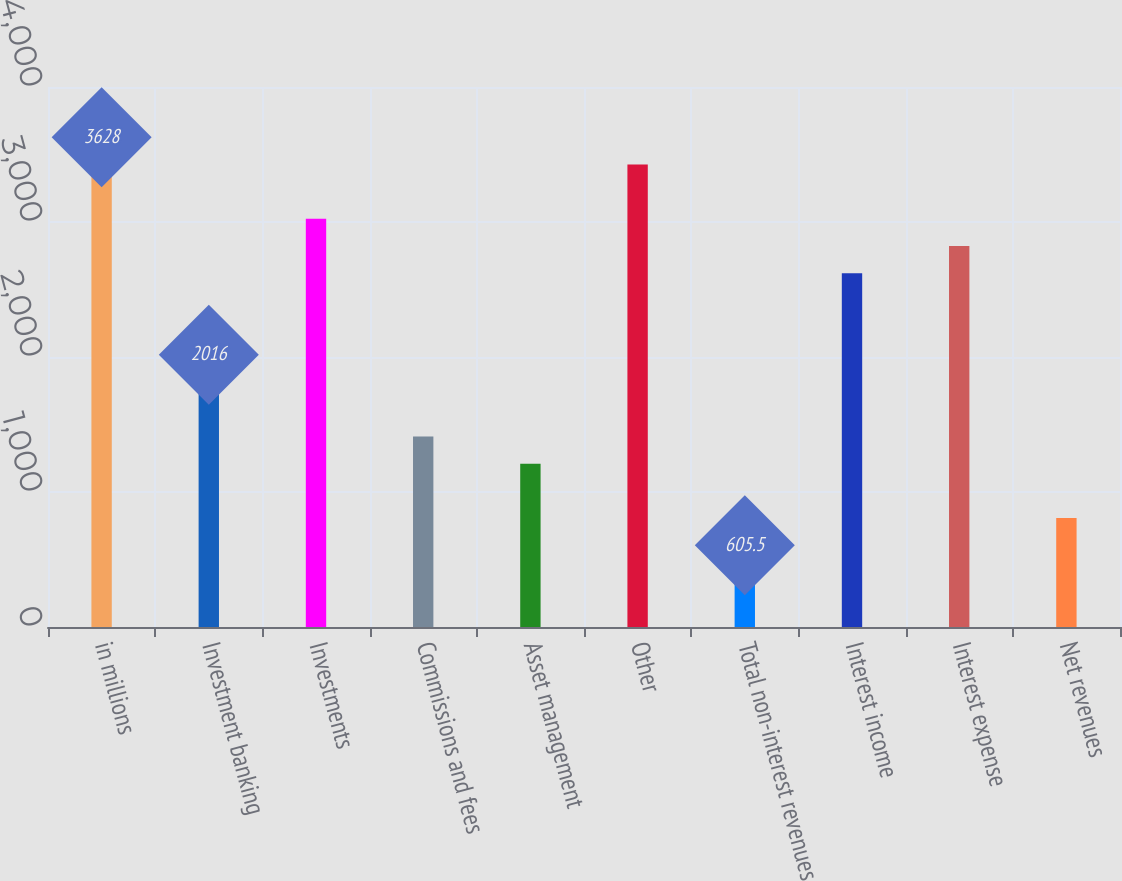<chart> <loc_0><loc_0><loc_500><loc_500><bar_chart><fcel>in millions<fcel>Investment banking<fcel>Investments<fcel>Commissions and fees<fcel>Asset management<fcel>Other<fcel>Total non-interest revenues<fcel>Interest income<fcel>Interest expense<fcel>Net revenues<nl><fcel>3628<fcel>2016<fcel>3023.5<fcel>1411.5<fcel>1210<fcel>3426.5<fcel>605.5<fcel>2620.5<fcel>2822<fcel>807<nl></chart> 